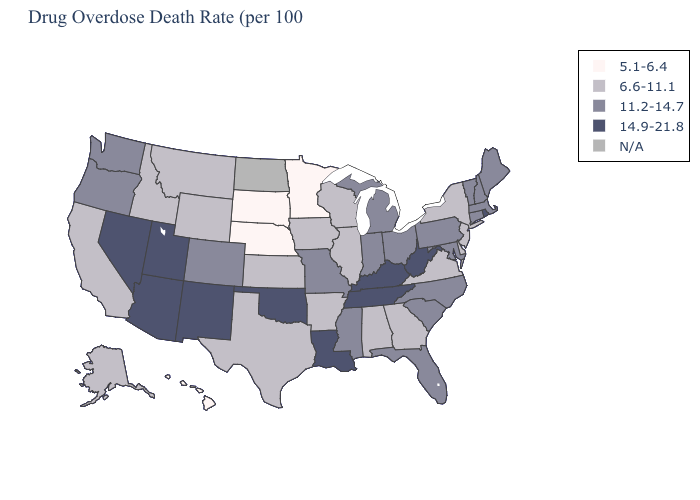Among the states that border Minnesota , which have the highest value?
Short answer required. Iowa, Wisconsin. Does the map have missing data?
Keep it brief. Yes. Which states have the lowest value in the MidWest?
Keep it brief. Minnesota, Nebraska, South Dakota. What is the highest value in the USA?
Keep it brief. 14.9-21.8. Does Louisiana have the highest value in the South?
Give a very brief answer. Yes. Does Missouri have the highest value in the MidWest?
Quick response, please. Yes. Is the legend a continuous bar?
Keep it brief. No. Name the states that have a value in the range 11.2-14.7?
Write a very short answer. Colorado, Connecticut, Florida, Indiana, Maine, Maryland, Massachusetts, Michigan, Mississippi, Missouri, New Hampshire, North Carolina, Ohio, Oregon, Pennsylvania, South Carolina, Vermont, Washington. Name the states that have a value in the range 11.2-14.7?
Be succinct. Colorado, Connecticut, Florida, Indiana, Maine, Maryland, Massachusetts, Michigan, Mississippi, Missouri, New Hampshire, North Carolina, Ohio, Oregon, Pennsylvania, South Carolina, Vermont, Washington. Which states have the lowest value in the West?
Give a very brief answer. Hawaii. Name the states that have a value in the range 6.6-11.1?
Concise answer only. Alabama, Alaska, Arkansas, California, Delaware, Georgia, Idaho, Illinois, Iowa, Kansas, Montana, New Jersey, New York, Texas, Virginia, Wisconsin, Wyoming. Which states have the lowest value in the MidWest?
Short answer required. Minnesota, Nebraska, South Dakota. What is the lowest value in the USA?
Concise answer only. 5.1-6.4. What is the value of Florida?
Concise answer only. 11.2-14.7. Among the states that border New York , which have the lowest value?
Keep it brief. New Jersey. 